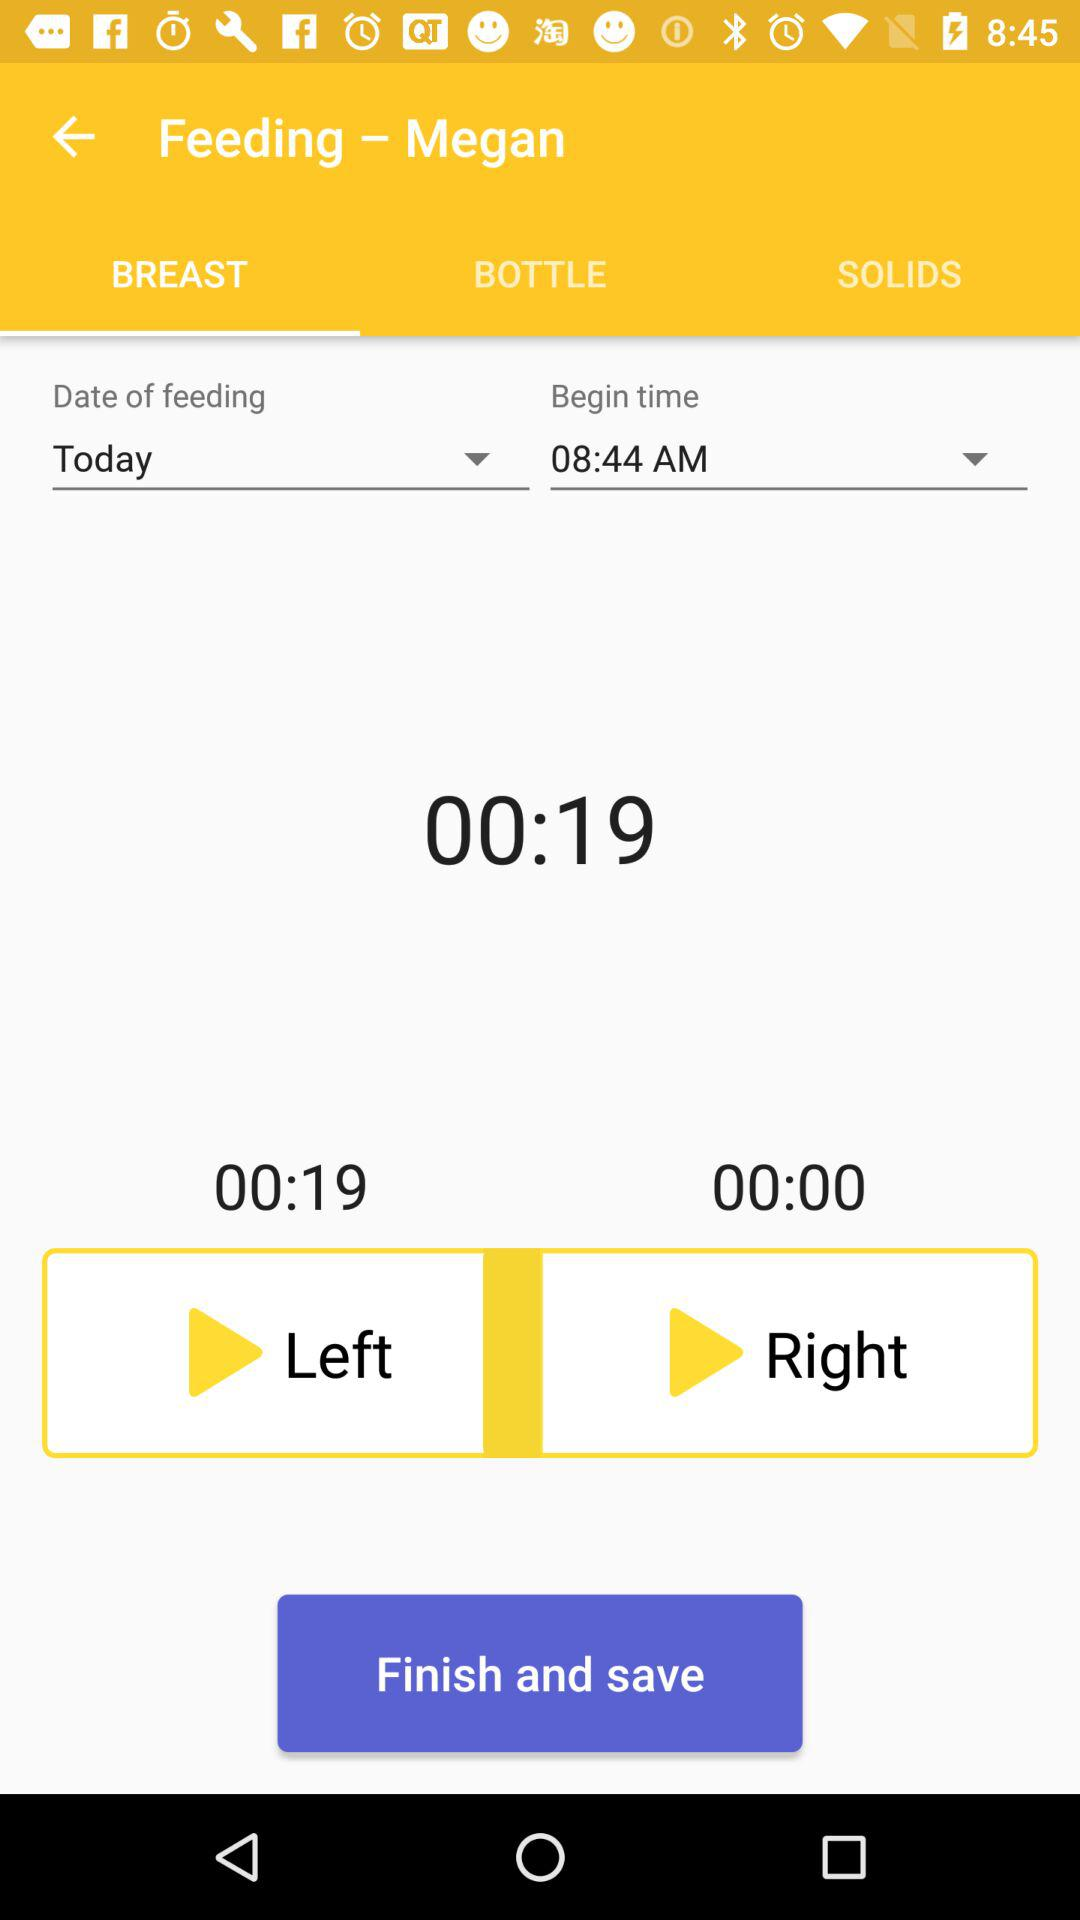What is the name of the baby? The name of the baby is Megan. 